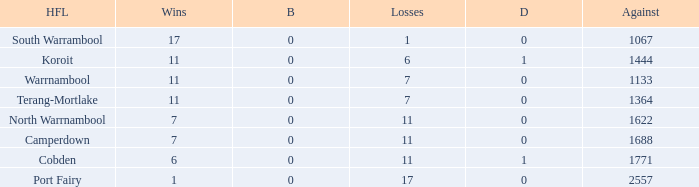Help me parse the entirety of this table. {'header': ['HFL', 'Wins', 'B', 'Losses', 'D', 'Against'], 'rows': [['South Warrambool', '17', '0', '1', '0', '1067'], ['Koroit', '11', '0', '6', '1', '1444'], ['Warrnambool', '11', '0', '7', '0', '1133'], ['Terang-Mortlake', '11', '0', '7', '0', '1364'], ['North Warrnambool', '7', '0', '11', '0', '1622'], ['Camperdown', '7', '0', '11', '0', '1688'], ['Cobden', '6', '0', '11', '1', '1771'], ['Port Fairy', '1', '0', '17', '0', '2557']]} What were the losses when the byes were less than 0? None. 